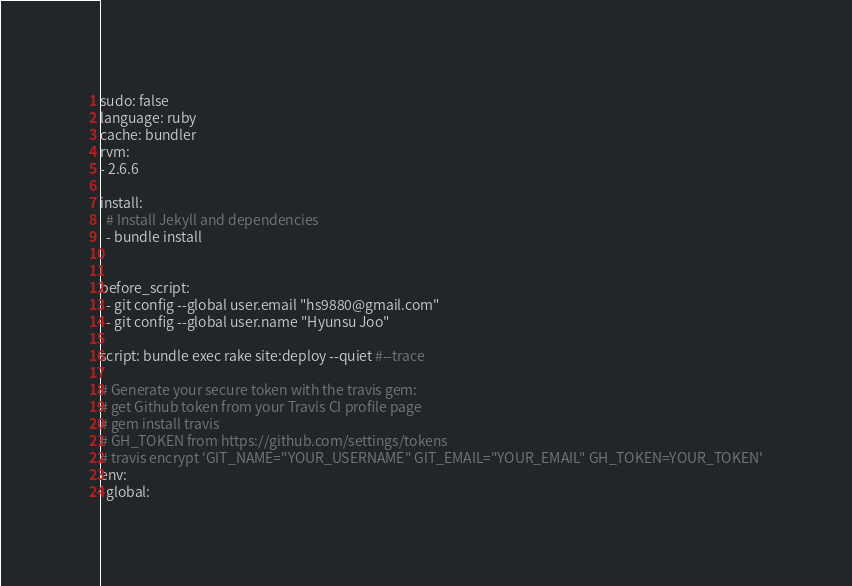Convert code to text. <code><loc_0><loc_0><loc_500><loc_500><_YAML_>sudo: false
language: ruby
cache: bundler
rvm:
- 2.6.6

install:
  # Install Jekyll and dependencies
  - bundle install


before_script:
  - git config --global user.email "hs9880@gmail.com"
  - git config --global user.name "Hyunsu Joo"

script: bundle exec rake site:deploy --quiet #--trace

# Generate your secure token with the travis gem:
# get Github token from your Travis CI profile page
# gem install travis
# GH_TOKEN from https://github.com/settings/tokens
# travis encrypt 'GIT_NAME="YOUR_USERNAME" GIT_EMAIL="YOUR_EMAIL" GH_TOKEN=YOUR_TOKEN'
env:
  global:</code> 